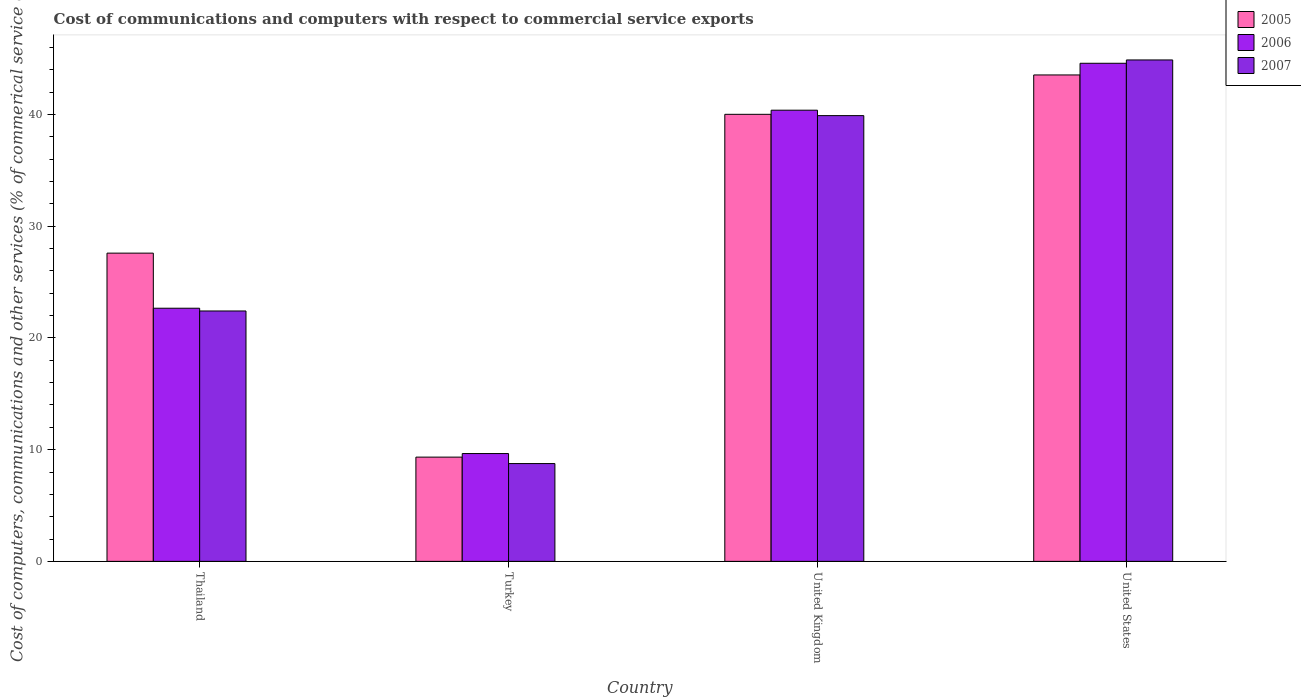How many different coloured bars are there?
Your answer should be compact. 3. Are the number of bars per tick equal to the number of legend labels?
Provide a short and direct response. Yes. What is the cost of communications and computers in 2007 in Turkey?
Your answer should be compact. 8.76. Across all countries, what is the maximum cost of communications and computers in 2007?
Your answer should be very brief. 44.89. Across all countries, what is the minimum cost of communications and computers in 2007?
Provide a short and direct response. 8.76. What is the total cost of communications and computers in 2007 in the graph?
Your answer should be compact. 115.98. What is the difference between the cost of communications and computers in 2007 in United Kingdom and that in United States?
Provide a succinct answer. -4.98. What is the difference between the cost of communications and computers in 2007 in Turkey and the cost of communications and computers in 2005 in United States?
Your answer should be very brief. -34.79. What is the average cost of communications and computers in 2005 per country?
Offer a very short reply. 30.13. What is the difference between the cost of communications and computers of/in 2007 and cost of communications and computers of/in 2006 in United Kingdom?
Offer a terse response. -0.48. What is the ratio of the cost of communications and computers in 2006 in Thailand to that in United States?
Your response must be concise. 0.51. Is the cost of communications and computers in 2006 in Turkey less than that in United Kingdom?
Give a very brief answer. Yes. Is the difference between the cost of communications and computers in 2007 in Thailand and Turkey greater than the difference between the cost of communications and computers in 2006 in Thailand and Turkey?
Ensure brevity in your answer.  Yes. What is the difference between the highest and the second highest cost of communications and computers in 2006?
Your response must be concise. -4.2. What is the difference between the highest and the lowest cost of communications and computers in 2006?
Provide a short and direct response. 34.94. In how many countries, is the cost of communications and computers in 2005 greater than the average cost of communications and computers in 2005 taken over all countries?
Ensure brevity in your answer.  2. What does the 3rd bar from the right in United Kingdom represents?
Keep it short and to the point. 2005. Is it the case that in every country, the sum of the cost of communications and computers in 2007 and cost of communications and computers in 2006 is greater than the cost of communications and computers in 2005?
Provide a short and direct response. Yes. Are all the bars in the graph horizontal?
Your response must be concise. No. How many countries are there in the graph?
Provide a short and direct response. 4. What is the difference between two consecutive major ticks on the Y-axis?
Offer a very short reply. 10. Does the graph contain grids?
Keep it short and to the point. No. Where does the legend appear in the graph?
Your answer should be very brief. Top right. What is the title of the graph?
Give a very brief answer. Cost of communications and computers with respect to commercial service exports. What is the label or title of the Y-axis?
Give a very brief answer. Cost of computers, communications and other services (% of commerical service exports). What is the Cost of computers, communications and other services (% of commerical service exports) in 2005 in Thailand?
Keep it short and to the point. 27.6. What is the Cost of computers, communications and other services (% of commerical service exports) of 2006 in Thailand?
Ensure brevity in your answer.  22.66. What is the Cost of computers, communications and other services (% of commerical service exports) of 2007 in Thailand?
Your answer should be very brief. 22.42. What is the Cost of computers, communications and other services (% of commerical service exports) in 2005 in Turkey?
Your answer should be compact. 9.33. What is the Cost of computers, communications and other services (% of commerical service exports) in 2006 in Turkey?
Offer a very short reply. 9.65. What is the Cost of computers, communications and other services (% of commerical service exports) in 2007 in Turkey?
Provide a succinct answer. 8.76. What is the Cost of computers, communications and other services (% of commerical service exports) in 2005 in United Kingdom?
Your response must be concise. 40.03. What is the Cost of computers, communications and other services (% of commerical service exports) of 2006 in United Kingdom?
Make the answer very short. 40.39. What is the Cost of computers, communications and other services (% of commerical service exports) in 2007 in United Kingdom?
Ensure brevity in your answer.  39.91. What is the Cost of computers, communications and other services (% of commerical service exports) in 2005 in United States?
Give a very brief answer. 43.55. What is the Cost of computers, communications and other services (% of commerical service exports) of 2006 in United States?
Your response must be concise. 44.6. What is the Cost of computers, communications and other services (% of commerical service exports) of 2007 in United States?
Offer a terse response. 44.89. Across all countries, what is the maximum Cost of computers, communications and other services (% of commerical service exports) in 2005?
Your response must be concise. 43.55. Across all countries, what is the maximum Cost of computers, communications and other services (% of commerical service exports) of 2006?
Your answer should be compact. 44.6. Across all countries, what is the maximum Cost of computers, communications and other services (% of commerical service exports) in 2007?
Offer a terse response. 44.89. Across all countries, what is the minimum Cost of computers, communications and other services (% of commerical service exports) in 2005?
Offer a terse response. 9.33. Across all countries, what is the minimum Cost of computers, communications and other services (% of commerical service exports) in 2006?
Your response must be concise. 9.65. Across all countries, what is the minimum Cost of computers, communications and other services (% of commerical service exports) of 2007?
Make the answer very short. 8.76. What is the total Cost of computers, communications and other services (% of commerical service exports) of 2005 in the graph?
Your answer should be compact. 120.51. What is the total Cost of computers, communications and other services (% of commerical service exports) in 2006 in the graph?
Your response must be concise. 117.31. What is the total Cost of computers, communications and other services (% of commerical service exports) in 2007 in the graph?
Provide a short and direct response. 115.98. What is the difference between the Cost of computers, communications and other services (% of commerical service exports) in 2005 in Thailand and that in Turkey?
Keep it short and to the point. 18.26. What is the difference between the Cost of computers, communications and other services (% of commerical service exports) in 2006 in Thailand and that in Turkey?
Your answer should be compact. 13.01. What is the difference between the Cost of computers, communications and other services (% of commerical service exports) in 2007 in Thailand and that in Turkey?
Your answer should be very brief. 13.66. What is the difference between the Cost of computers, communications and other services (% of commerical service exports) of 2005 in Thailand and that in United Kingdom?
Provide a succinct answer. -12.43. What is the difference between the Cost of computers, communications and other services (% of commerical service exports) of 2006 in Thailand and that in United Kingdom?
Your answer should be compact. -17.73. What is the difference between the Cost of computers, communications and other services (% of commerical service exports) of 2007 in Thailand and that in United Kingdom?
Offer a very short reply. -17.49. What is the difference between the Cost of computers, communications and other services (% of commerical service exports) of 2005 in Thailand and that in United States?
Keep it short and to the point. -15.95. What is the difference between the Cost of computers, communications and other services (% of commerical service exports) of 2006 in Thailand and that in United States?
Make the answer very short. -21.93. What is the difference between the Cost of computers, communications and other services (% of commerical service exports) in 2007 in Thailand and that in United States?
Your answer should be compact. -22.48. What is the difference between the Cost of computers, communications and other services (% of commerical service exports) in 2005 in Turkey and that in United Kingdom?
Give a very brief answer. -30.69. What is the difference between the Cost of computers, communications and other services (% of commerical service exports) in 2006 in Turkey and that in United Kingdom?
Offer a very short reply. -30.74. What is the difference between the Cost of computers, communications and other services (% of commerical service exports) of 2007 in Turkey and that in United Kingdom?
Provide a short and direct response. -31.15. What is the difference between the Cost of computers, communications and other services (% of commerical service exports) in 2005 in Turkey and that in United States?
Your answer should be compact. -34.22. What is the difference between the Cost of computers, communications and other services (% of commerical service exports) of 2006 in Turkey and that in United States?
Your response must be concise. -34.94. What is the difference between the Cost of computers, communications and other services (% of commerical service exports) in 2007 in Turkey and that in United States?
Give a very brief answer. -36.14. What is the difference between the Cost of computers, communications and other services (% of commerical service exports) of 2005 in United Kingdom and that in United States?
Keep it short and to the point. -3.53. What is the difference between the Cost of computers, communications and other services (% of commerical service exports) in 2006 in United Kingdom and that in United States?
Offer a very short reply. -4.2. What is the difference between the Cost of computers, communications and other services (% of commerical service exports) of 2007 in United Kingdom and that in United States?
Provide a short and direct response. -4.98. What is the difference between the Cost of computers, communications and other services (% of commerical service exports) in 2005 in Thailand and the Cost of computers, communications and other services (% of commerical service exports) in 2006 in Turkey?
Ensure brevity in your answer.  17.94. What is the difference between the Cost of computers, communications and other services (% of commerical service exports) in 2005 in Thailand and the Cost of computers, communications and other services (% of commerical service exports) in 2007 in Turkey?
Keep it short and to the point. 18.84. What is the difference between the Cost of computers, communications and other services (% of commerical service exports) in 2006 in Thailand and the Cost of computers, communications and other services (% of commerical service exports) in 2007 in Turkey?
Keep it short and to the point. 13.91. What is the difference between the Cost of computers, communications and other services (% of commerical service exports) in 2005 in Thailand and the Cost of computers, communications and other services (% of commerical service exports) in 2006 in United Kingdom?
Provide a short and direct response. -12.8. What is the difference between the Cost of computers, communications and other services (% of commerical service exports) of 2005 in Thailand and the Cost of computers, communications and other services (% of commerical service exports) of 2007 in United Kingdom?
Your answer should be very brief. -12.31. What is the difference between the Cost of computers, communications and other services (% of commerical service exports) in 2006 in Thailand and the Cost of computers, communications and other services (% of commerical service exports) in 2007 in United Kingdom?
Your answer should be very brief. -17.25. What is the difference between the Cost of computers, communications and other services (% of commerical service exports) in 2005 in Thailand and the Cost of computers, communications and other services (% of commerical service exports) in 2006 in United States?
Your response must be concise. -17. What is the difference between the Cost of computers, communications and other services (% of commerical service exports) of 2005 in Thailand and the Cost of computers, communications and other services (% of commerical service exports) of 2007 in United States?
Give a very brief answer. -17.3. What is the difference between the Cost of computers, communications and other services (% of commerical service exports) of 2006 in Thailand and the Cost of computers, communications and other services (% of commerical service exports) of 2007 in United States?
Offer a terse response. -22.23. What is the difference between the Cost of computers, communications and other services (% of commerical service exports) in 2005 in Turkey and the Cost of computers, communications and other services (% of commerical service exports) in 2006 in United Kingdom?
Your response must be concise. -31.06. What is the difference between the Cost of computers, communications and other services (% of commerical service exports) of 2005 in Turkey and the Cost of computers, communications and other services (% of commerical service exports) of 2007 in United Kingdom?
Give a very brief answer. -30.58. What is the difference between the Cost of computers, communications and other services (% of commerical service exports) of 2006 in Turkey and the Cost of computers, communications and other services (% of commerical service exports) of 2007 in United Kingdom?
Provide a succinct answer. -30.26. What is the difference between the Cost of computers, communications and other services (% of commerical service exports) in 2005 in Turkey and the Cost of computers, communications and other services (% of commerical service exports) in 2006 in United States?
Provide a short and direct response. -35.26. What is the difference between the Cost of computers, communications and other services (% of commerical service exports) in 2005 in Turkey and the Cost of computers, communications and other services (% of commerical service exports) in 2007 in United States?
Keep it short and to the point. -35.56. What is the difference between the Cost of computers, communications and other services (% of commerical service exports) of 2006 in Turkey and the Cost of computers, communications and other services (% of commerical service exports) of 2007 in United States?
Your response must be concise. -35.24. What is the difference between the Cost of computers, communications and other services (% of commerical service exports) of 2005 in United Kingdom and the Cost of computers, communications and other services (% of commerical service exports) of 2006 in United States?
Keep it short and to the point. -4.57. What is the difference between the Cost of computers, communications and other services (% of commerical service exports) in 2005 in United Kingdom and the Cost of computers, communications and other services (% of commerical service exports) in 2007 in United States?
Provide a short and direct response. -4.87. What is the difference between the Cost of computers, communications and other services (% of commerical service exports) in 2006 in United Kingdom and the Cost of computers, communications and other services (% of commerical service exports) in 2007 in United States?
Your answer should be very brief. -4.5. What is the average Cost of computers, communications and other services (% of commerical service exports) in 2005 per country?
Your answer should be very brief. 30.13. What is the average Cost of computers, communications and other services (% of commerical service exports) of 2006 per country?
Your response must be concise. 29.33. What is the average Cost of computers, communications and other services (% of commerical service exports) in 2007 per country?
Offer a terse response. 28.99. What is the difference between the Cost of computers, communications and other services (% of commerical service exports) of 2005 and Cost of computers, communications and other services (% of commerical service exports) of 2006 in Thailand?
Your answer should be compact. 4.93. What is the difference between the Cost of computers, communications and other services (% of commerical service exports) of 2005 and Cost of computers, communications and other services (% of commerical service exports) of 2007 in Thailand?
Your response must be concise. 5.18. What is the difference between the Cost of computers, communications and other services (% of commerical service exports) of 2006 and Cost of computers, communications and other services (% of commerical service exports) of 2007 in Thailand?
Your answer should be compact. 0.25. What is the difference between the Cost of computers, communications and other services (% of commerical service exports) in 2005 and Cost of computers, communications and other services (% of commerical service exports) in 2006 in Turkey?
Your response must be concise. -0.32. What is the difference between the Cost of computers, communications and other services (% of commerical service exports) of 2005 and Cost of computers, communications and other services (% of commerical service exports) of 2007 in Turkey?
Your response must be concise. 0.58. What is the difference between the Cost of computers, communications and other services (% of commerical service exports) of 2006 and Cost of computers, communications and other services (% of commerical service exports) of 2007 in Turkey?
Keep it short and to the point. 0.9. What is the difference between the Cost of computers, communications and other services (% of commerical service exports) of 2005 and Cost of computers, communications and other services (% of commerical service exports) of 2006 in United Kingdom?
Your response must be concise. -0.37. What is the difference between the Cost of computers, communications and other services (% of commerical service exports) of 2005 and Cost of computers, communications and other services (% of commerical service exports) of 2007 in United Kingdom?
Keep it short and to the point. 0.12. What is the difference between the Cost of computers, communications and other services (% of commerical service exports) of 2006 and Cost of computers, communications and other services (% of commerical service exports) of 2007 in United Kingdom?
Provide a succinct answer. 0.48. What is the difference between the Cost of computers, communications and other services (% of commerical service exports) in 2005 and Cost of computers, communications and other services (% of commerical service exports) in 2006 in United States?
Keep it short and to the point. -1.05. What is the difference between the Cost of computers, communications and other services (% of commerical service exports) in 2005 and Cost of computers, communications and other services (% of commerical service exports) in 2007 in United States?
Keep it short and to the point. -1.34. What is the difference between the Cost of computers, communications and other services (% of commerical service exports) of 2006 and Cost of computers, communications and other services (% of commerical service exports) of 2007 in United States?
Give a very brief answer. -0.3. What is the ratio of the Cost of computers, communications and other services (% of commerical service exports) in 2005 in Thailand to that in Turkey?
Make the answer very short. 2.96. What is the ratio of the Cost of computers, communications and other services (% of commerical service exports) of 2006 in Thailand to that in Turkey?
Give a very brief answer. 2.35. What is the ratio of the Cost of computers, communications and other services (% of commerical service exports) in 2007 in Thailand to that in Turkey?
Provide a short and direct response. 2.56. What is the ratio of the Cost of computers, communications and other services (% of commerical service exports) in 2005 in Thailand to that in United Kingdom?
Keep it short and to the point. 0.69. What is the ratio of the Cost of computers, communications and other services (% of commerical service exports) in 2006 in Thailand to that in United Kingdom?
Your response must be concise. 0.56. What is the ratio of the Cost of computers, communications and other services (% of commerical service exports) in 2007 in Thailand to that in United Kingdom?
Offer a very short reply. 0.56. What is the ratio of the Cost of computers, communications and other services (% of commerical service exports) in 2005 in Thailand to that in United States?
Keep it short and to the point. 0.63. What is the ratio of the Cost of computers, communications and other services (% of commerical service exports) in 2006 in Thailand to that in United States?
Offer a terse response. 0.51. What is the ratio of the Cost of computers, communications and other services (% of commerical service exports) of 2007 in Thailand to that in United States?
Ensure brevity in your answer.  0.5. What is the ratio of the Cost of computers, communications and other services (% of commerical service exports) in 2005 in Turkey to that in United Kingdom?
Your answer should be very brief. 0.23. What is the ratio of the Cost of computers, communications and other services (% of commerical service exports) in 2006 in Turkey to that in United Kingdom?
Keep it short and to the point. 0.24. What is the ratio of the Cost of computers, communications and other services (% of commerical service exports) in 2007 in Turkey to that in United Kingdom?
Give a very brief answer. 0.22. What is the ratio of the Cost of computers, communications and other services (% of commerical service exports) of 2005 in Turkey to that in United States?
Ensure brevity in your answer.  0.21. What is the ratio of the Cost of computers, communications and other services (% of commerical service exports) in 2006 in Turkey to that in United States?
Your response must be concise. 0.22. What is the ratio of the Cost of computers, communications and other services (% of commerical service exports) of 2007 in Turkey to that in United States?
Offer a very short reply. 0.2. What is the ratio of the Cost of computers, communications and other services (% of commerical service exports) in 2005 in United Kingdom to that in United States?
Ensure brevity in your answer.  0.92. What is the ratio of the Cost of computers, communications and other services (% of commerical service exports) of 2006 in United Kingdom to that in United States?
Provide a short and direct response. 0.91. What is the ratio of the Cost of computers, communications and other services (% of commerical service exports) in 2007 in United Kingdom to that in United States?
Provide a short and direct response. 0.89. What is the difference between the highest and the second highest Cost of computers, communications and other services (% of commerical service exports) of 2005?
Your response must be concise. 3.53. What is the difference between the highest and the second highest Cost of computers, communications and other services (% of commerical service exports) in 2006?
Make the answer very short. 4.2. What is the difference between the highest and the second highest Cost of computers, communications and other services (% of commerical service exports) of 2007?
Provide a succinct answer. 4.98. What is the difference between the highest and the lowest Cost of computers, communications and other services (% of commerical service exports) in 2005?
Your answer should be compact. 34.22. What is the difference between the highest and the lowest Cost of computers, communications and other services (% of commerical service exports) of 2006?
Give a very brief answer. 34.94. What is the difference between the highest and the lowest Cost of computers, communications and other services (% of commerical service exports) in 2007?
Offer a very short reply. 36.14. 